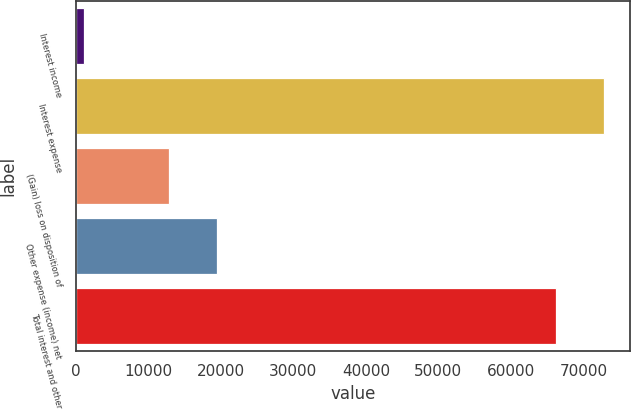Convert chart. <chart><loc_0><loc_0><loc_500><loc_500><bar_chart><fcel>Interest income<fcel>Interest expense<fcel>(Gain) loss on disposition of<fcel>Other expense (income) net<fcel>Total interest and other<nl><fcel>1141<fcel>72784.5<fcel>12844<fcel>19427.5<fcel>66201<nl></chart> 